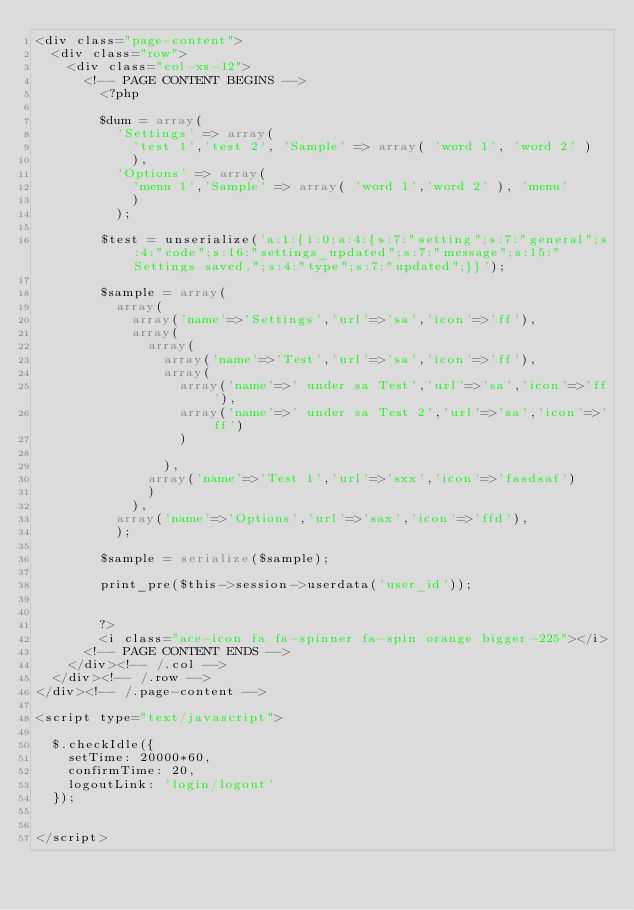<code> <loc_0><loc_0><loc_500><loc_500><_PHP_><div class="page-content">
	<div class="row">
		<div class="col-xs-12">
			<!-- PAGE CONTENT BEGINS -->
				<?php 

				$dum = array(
					'Settings' => array(
						'test 1','test 2', 'Sample' => array( 'word 1', 'word 2' )
						),
					'Options' => array(
						'menu 1','Sample' => array( 'word 1','word 2' ), 'menu'
						)
					);

				$test = unserialize('a:1:{i:0;a:4:{s:7:"setting";s:7:"general";s:4:"code";s:16:"settings_updated";s:7:"message";s:15:"Settings saved.";s:4:"type";s:7:"updated";}}');

				$sample = array(
					array(
						array('name'=>'Settings','url'=>'sa','icon'=>'ff'),
						array(
							array(
								array('name'=>'Test','url'=>'sa','icon'=>'ff'),
								array(
									array('name'=>' under sa Test','url'=>'sa','icon'=>'ff'),
									array('name'=>' under sa Test 2','url'=>'sa','icon'=>'ff')
									)

								),
							array('name'=>'Test 1','url'=>'sxx','icon'=>'fasdsaf')
							)
						),
					array('name'=>'Options','url'=>'sax','icon'=>'ffd'),
					);

				$sample = serialize($sample);

				print_pre($this->session->userdata('user_id'));

				
				?>
				<i class="ace-icon fa fa-spinner fa-spin orange bigger-225"></i>
			<!-- PAGE CONTENT ENDS -->
		</div><!-- /.col -->
	</div><!-- /.row -->
</div><!-- /.page-content -->

<script type="text/javascript">
	
	$.checkIdle({
		setTime: 20000*60,
		confirmTime: 20,
		logoutLink: 'login/logout'
	});


</script>  
</code> 